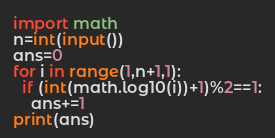Convert code to text. <code><loc_0><loc_0><loc_500><loc_500><_Python_>import math
n=int(input())
ans=0
for i in range(1,n+1,1):
  if (int(math.log10(i))+1)%2==1:
    ans+=1
print(ans)</code> 